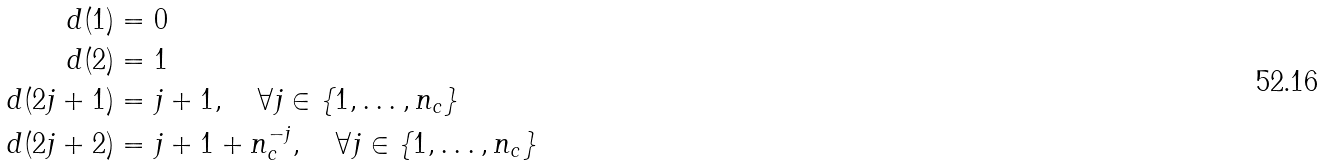Convert formula to latex. <formula><loc_0><loc_0><loc_500><loc_500>d ( 1 ) & = 0 \\ d ( 2 ) & = 1 \\ d ( 2 j + 1 ) & = j + 1 , \quad \forall j \in \{ 1 , \dots , n _ { c } \} \\ d ( 2 j + 2 ) & = j + 1 + n _ { c } ^ { - j } , \quad \forall j \in \{ 1 , \dots , n _ { c } \}</formula> 